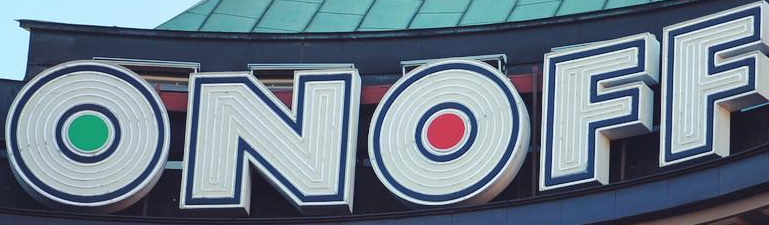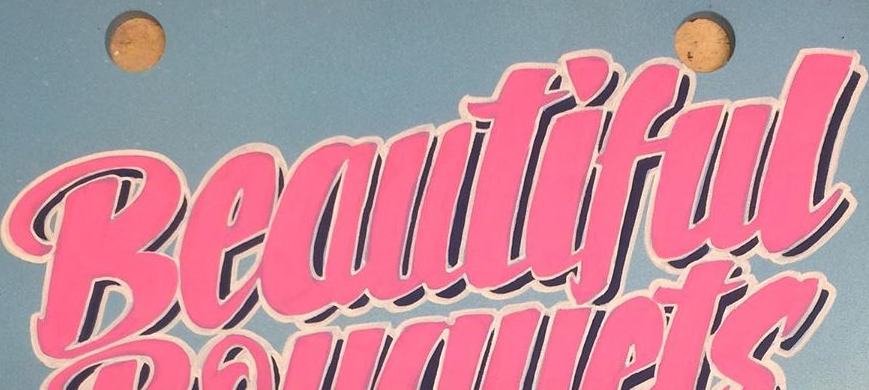What words can you see in these images in sequence, separated by a semicolon? ONOFF; Beautiful 